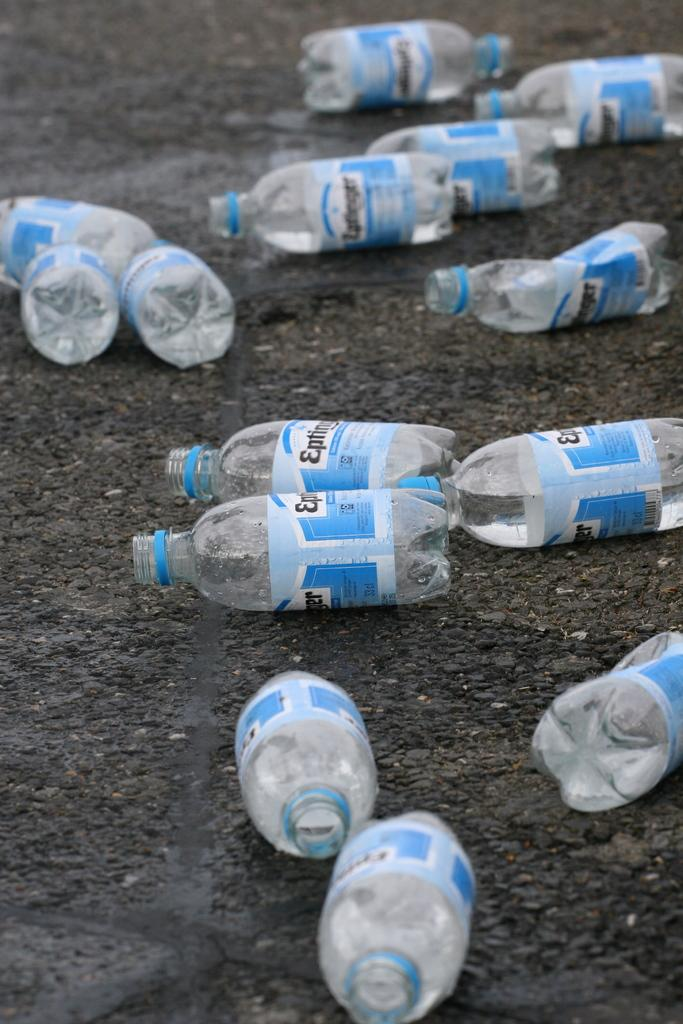<image>
Describe the image concisely. A bottle with a blue and white label with the beginning of the word EP. 